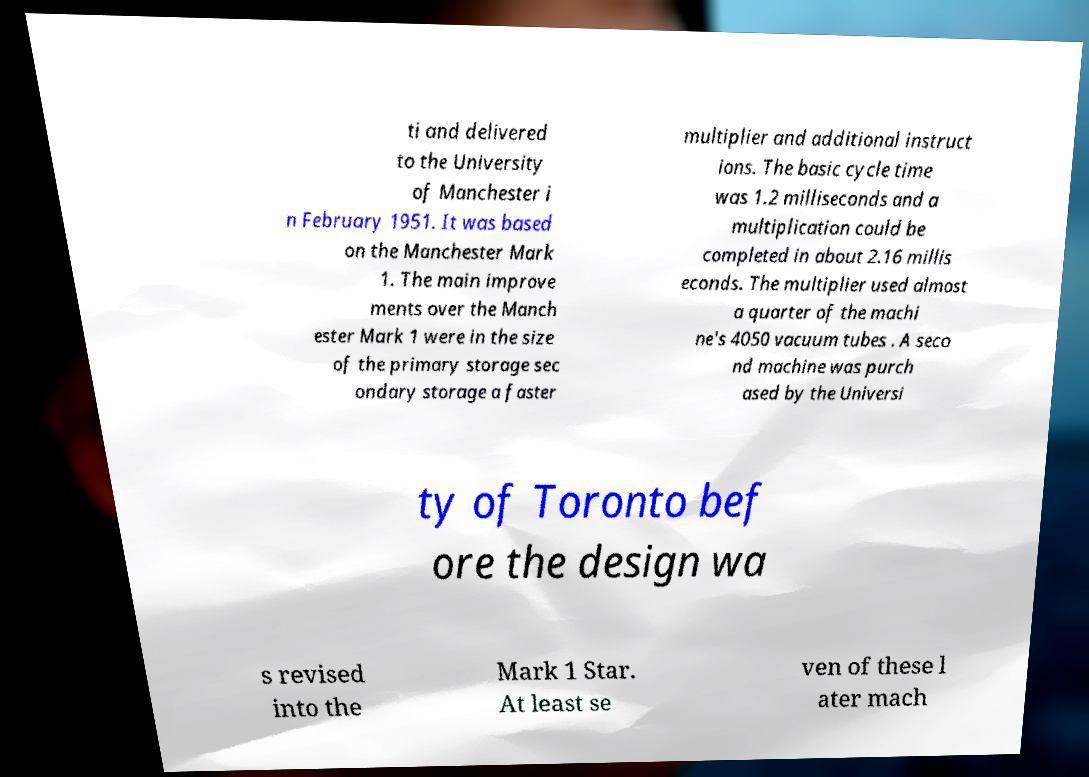What messages or text are displayed in this image? I need them in a readable, typed format. ti and delivered to the University of Manchester i n February 1951. It was based on the Manchester Mark 1. The main improve ments over the Manch ester Mark 1 were in the size of the primary storage sec ondary storage a faster multiplier and additional instruct ions. The basic cycle time was 1.2 milliseconds and a multiplication could be completed in about 2.16 millis econds. The multiplier used almost a quarter of the machi ne's 4050 vacuum tubes . A seco nd machine was purch ased by the Universi ty of Toronto bef ore the design wa s revised into the Mark 1 Star. At least se ven of these l ater mach 